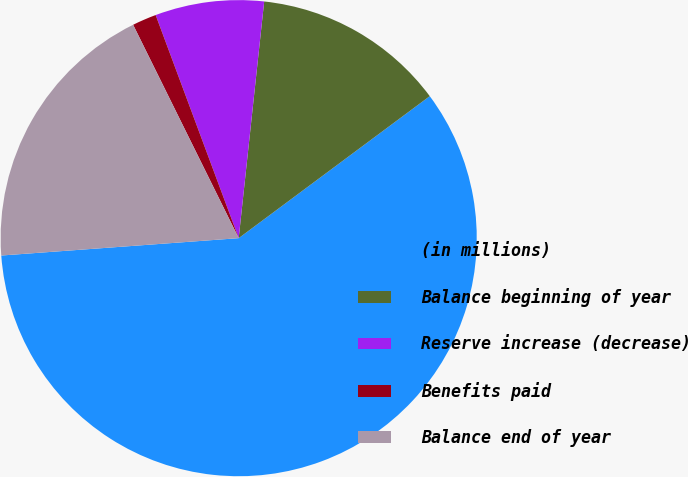Convert chart. <chart><loc_0><loc_0><loc_500><loc_500><pie_chart><fcel>(in millions)<fcel>Balance beginning of year<fcel>Reserve increase (decrease)<fcel>Benefits paid<fcel>Balance end of year<nl><fcel>59.01%<fcel>13.12%<fcel>7.38%<fcel>1.64%<fcel>18.85%<nl></chart> 